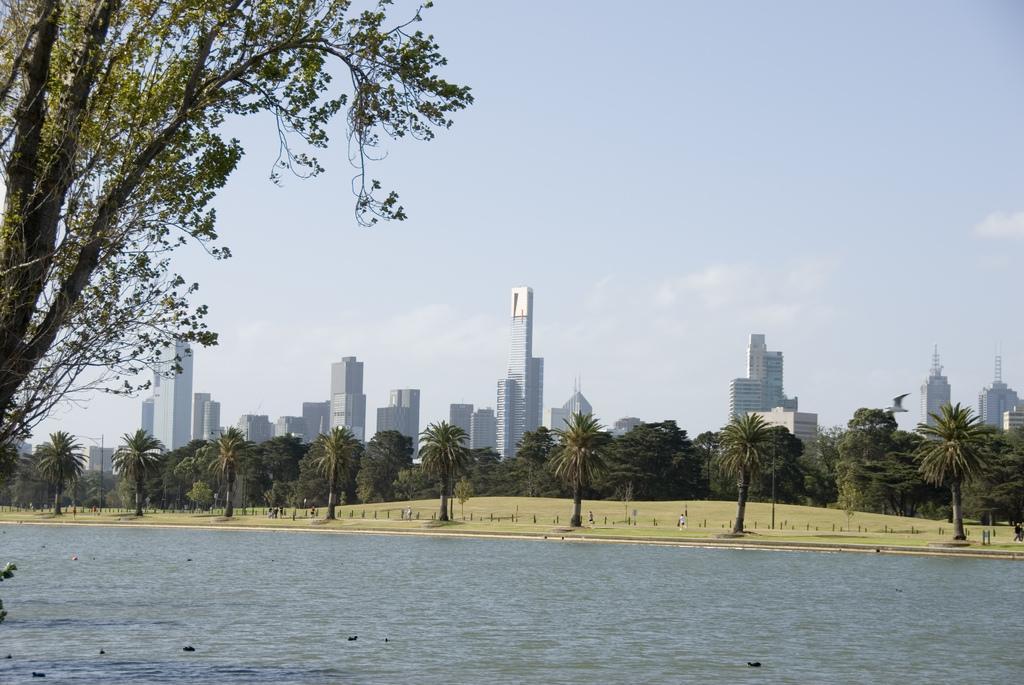Describe this image in one or two sentences. In this image, we can see some water with a few objects floating. There are a few buildings, poles and trees. We can see the ground and some grass. We can also see the sky with clouds. 